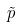Convert formula to latex. <formula><loc_0><loc_0><loc_500><loc_500>\tilde { p }</formula> 